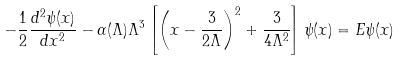<formula> <loc_0><loc_0><loc_500><loc_500>- \frac { 1 } { 2 } \frac { d ^ { 2 } \psi ( x ) } { d x ^ { 2 } } - \alpha ( \Lambda ) \Lambda ^ { 3 } \left [ \left ( x - \frac { 3 } { 2 \Lambda } \right ) ^ { 2 } + \frac { 3 } { 4 \Lambda ^ { 2 } } \right ] \psi ( x ) = E \psi ( x )</formula> 